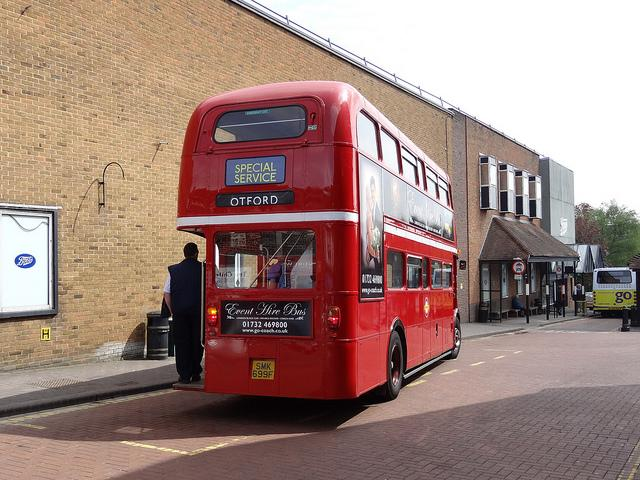What word is written before service? Please explain your reasoning. special. The sign on the front of the bus says "special service" in yellow. 